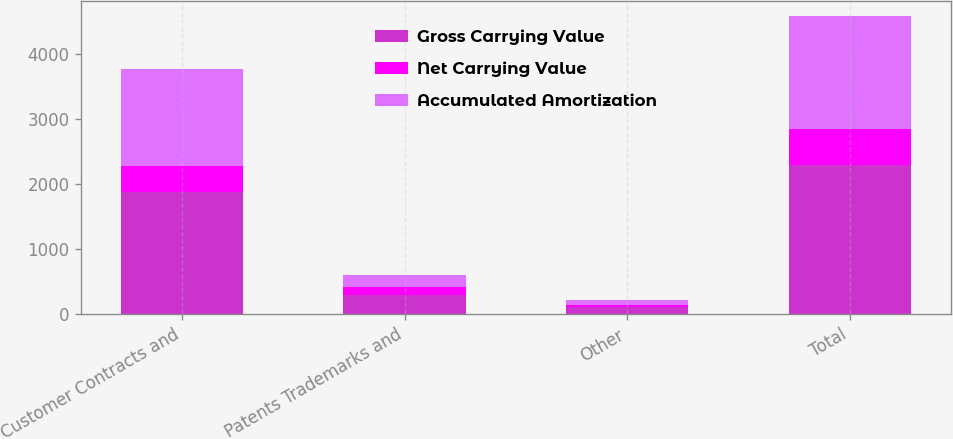<chart> <loc_0><loc_0><loc_500><loc_500><stacked_bar_chart><ecel><fcel>Customer Contracts and<fcel>Patents Trademarks and<fcel>Other<fcel>Total<nl><fcel>Gross Carrying Value<fcel>1879<fcel>302<fcel>109<fcel>2290<nl><fcel>Net Carrying Value<fcel>394<fcel>121<fcel>38<fcel>553<nl><fcel>Accumulated Amortization<fcel>1485<fcel>181<fcel>71<fcel>1737<nl></chart> 